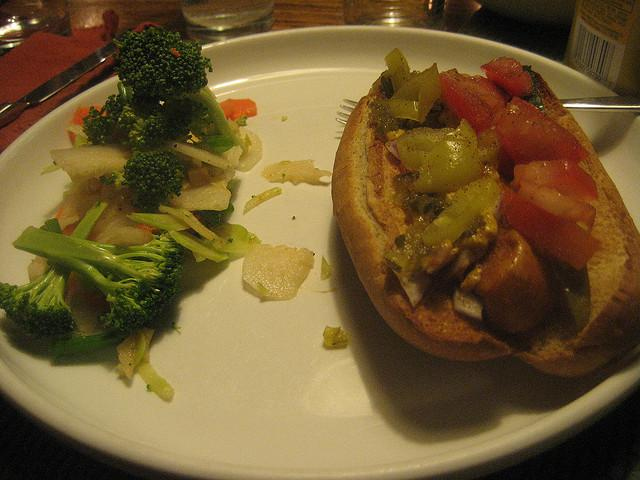What is on the left of the plate? broccoli 